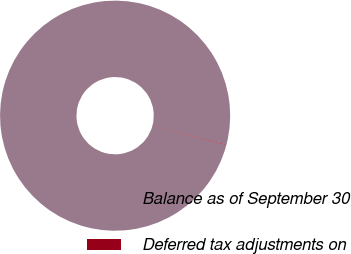Convert chart to OTSL. <chart><loc_0><loc_0><loc_500><loc_500><pie_chart><fcel>Balance as of September 30<fcel>Deferred tax adjustments on<nl><fcel>99.93%<fcel>0.07%<nl></chart> 